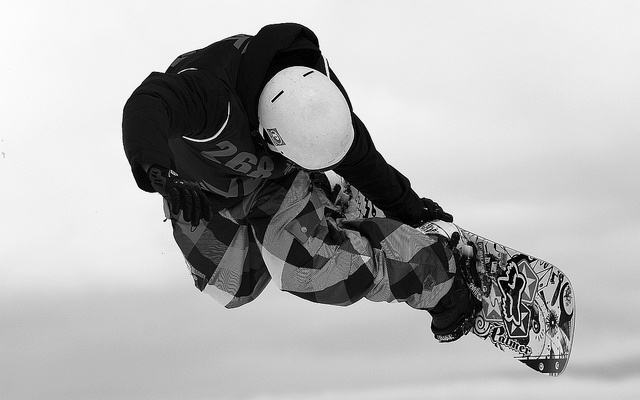Describe the objects in this image and their specific colors. I can see people in white, black, gray, darkgray, and lightgray tones and snowboard in white, black, darkgray, gray, and lightgray tones in this image. 